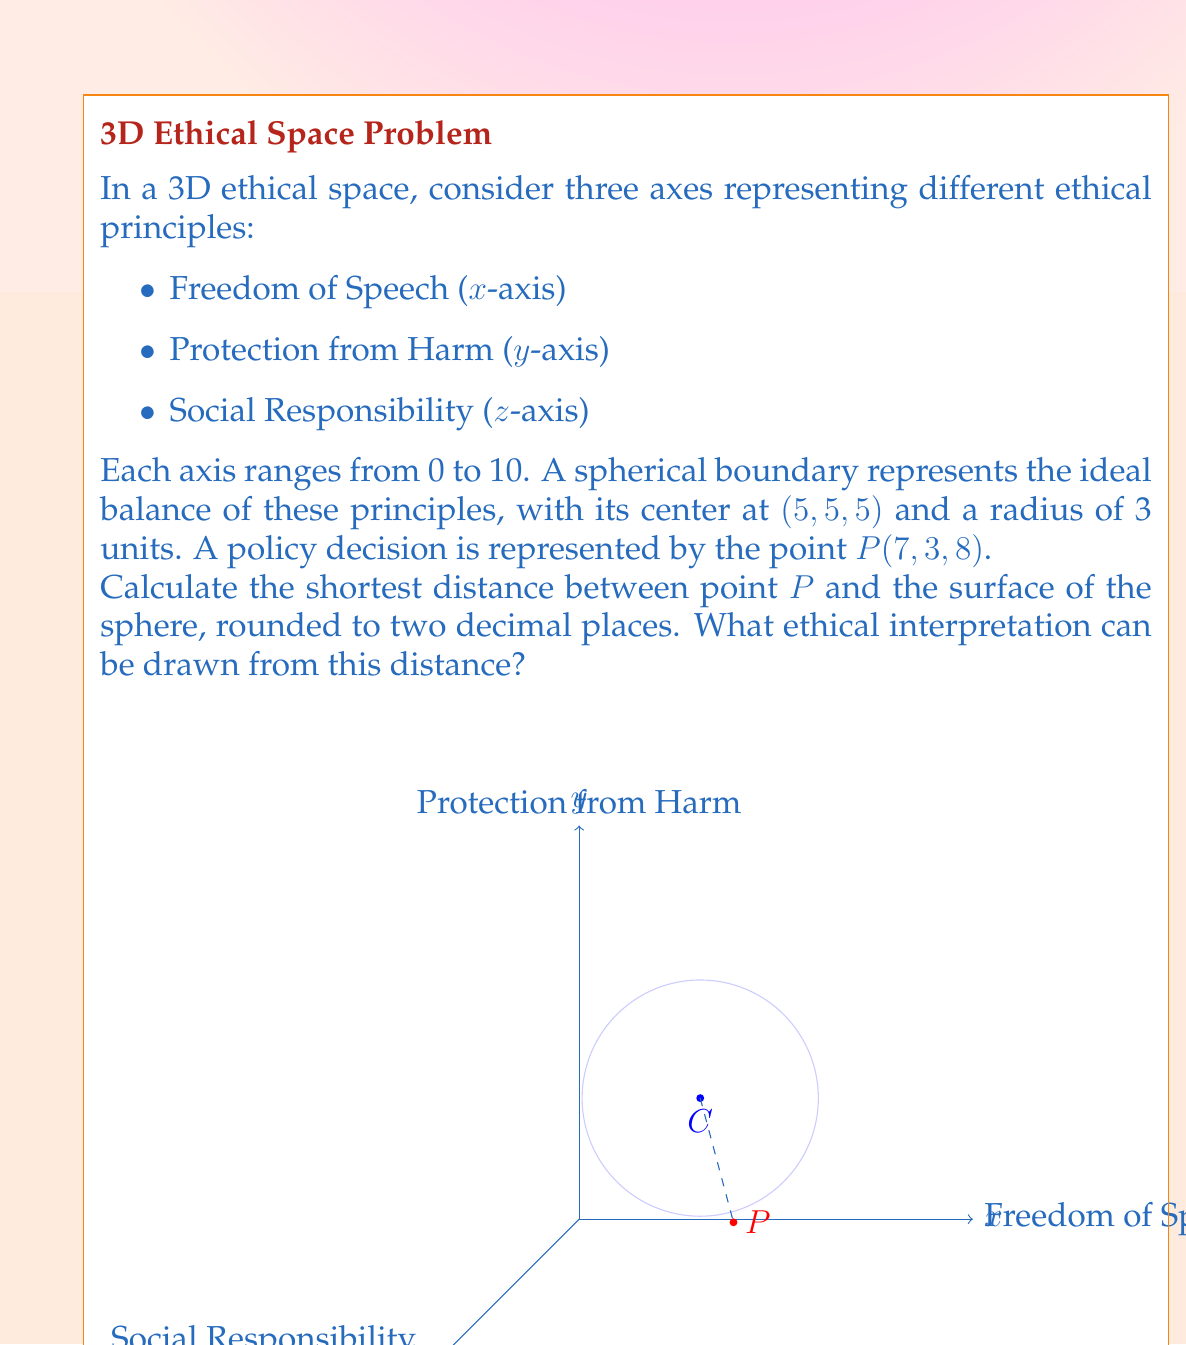Can you solve this math problem? Let's approach this step-by-step:

1) The center of the sphere C is at (5, 5, 5) and the point P is at (7, 3, 8).

2) To find the shortest distance between P and the surface of the sphere, we need to:
   a) Calculate the distance between P and C
   b) Subtract the radius of the sphere from this distance

3) The distance between P and C can be calculated using the 3D distance formula:

   $$d = \sqrt{(x_2-x_1)^2 + (y_2-y_1)^2 + (z_2-z_1)^2}$$

4) Plugging in the values:

   $$d = \sqrt{(7-5)^2 + (3-5)^2 + (8-5)^2}$$
   $$d = \sqrt{2^2 + (-2)^2 + 3^2}$$
   $$d = \sqrt{4 + 4 + 9}$$
   $$d = \sqrt{17}$$
   $$d \approx 4.12310562561766$$

5) The shortest distance to the surface is this distance minus the radius (3):

   $$4.12310562561766 - 3 = 1.12310562561766$$

6) Rounding to two decimal places: 1.12

7) Ethical interpretation: The distance of 1.12 units from the ideal balance (surface of the sphere) suggests that the policy decision represented by point P is somewhat out of balance. It leans more towards Freedom of Speech (7) and Social Responsibility (8), while potentially undervaluing Protection from Harm (3). This imbalance might need to be addressed to achieve a more ethically balanced policy.
Answer: 1.12 units; policy decision is imbalanced, favoring freedom of speech and social responsibility over protection from harm. 